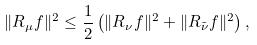Convert formula to latex. <formula><loc_0><loc_0><loc_500><loc_500>\| R _ { \mu } f \| ^ { 2 } \leq \frac { 1 } { 2 } \left ( \| R _ { \nu } f \| ^ { 2 } + \| R _ { \tilde { \nu } } f \| ^ { 2 } \right ) ,</formula> 